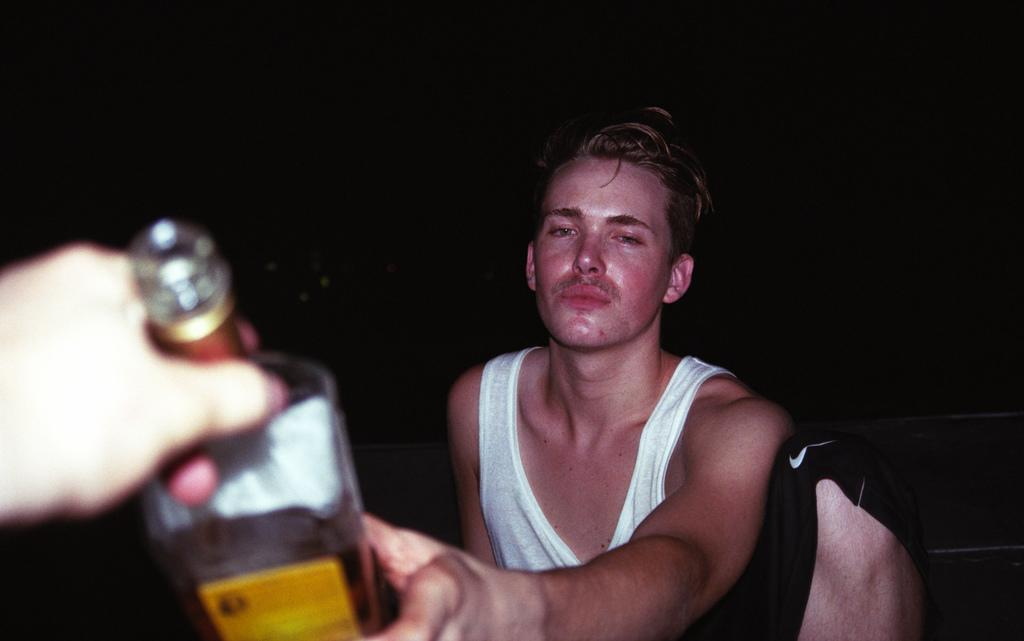Who or what is the main subject in the image? There is a person in the image. What is the person holding in the image? The person is holding a wine bottle. What color is the background of the image? The background of the image is black. What is the person wearing in the image? The person is wearing a black short. What type of plants can be seen growing on the person's head in the image? There are no plants visible on the person's head in the image. 